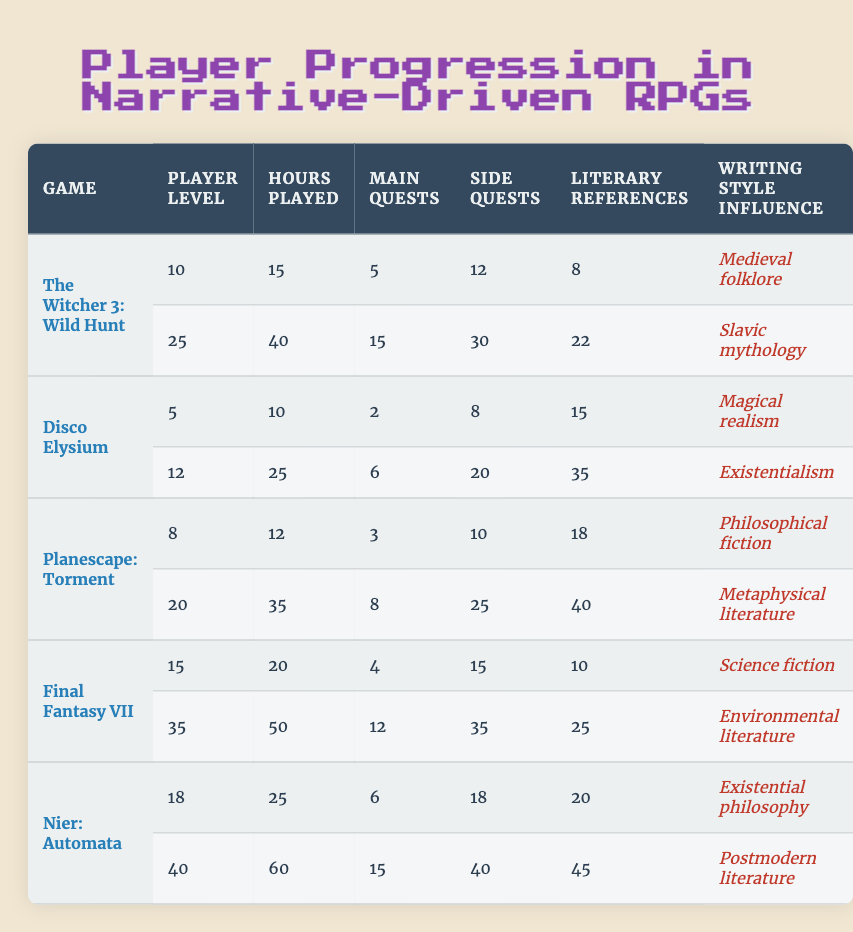What's the highest player level achieved in "Final Fantasy VII"? From the table, "Final Fantasy VII" shows two entries: one with a player level of 15 and another with a level of 35. Therefore, the highest player level is 35.
Answer: 35 Which game has the most hours played across all its entries? The games and their hours are as follows: "The Witcher 3: Wild Hunt" (15 + 40 = 55), "Disco Elysium" (10 + 25 = 35), "Planescape: Torment" (12 + 35 = 47), "Final Fantasy VII" (20 + 50 = 70), and "Nier: Automata" (25 + 60 = 85). So, "Nier: Automata" has the most hours played with a total of 85.
Answer: Nier: Automata How many main quests have been completed in total across all games? To find the total, we sum the main quests completed: 5 (Witcher 3) + 15 (Witcher 3) + 2 (Disco Elysium) + 6 (Disco Elysium) + 3 (Planescape) + 8 (Planescape) + 4 (Final Fantasy) + 12 (Final Fantasy) + 6 (Nier) + 15 (Nier) = 72. Thus, the total of main quests completed is 72.
Answer: 72 Is there a game that has played more than 50 hours at the level of 40? From the table, "Nier: Automata" is the only game with a player level of 40 and it has 60 hours played. Therefore, yes, it meets the criteria.
Answer: Yes Which game had the highest number of literary references encountered? The entries detail the literary references for each game: Witcher 3 (8 + 22 = 30), Disco Elysium (15 + 35 = 50), Planescape Torment (18 + 40 = 58), Final Fantasy (10 + 25 = 35), Nier Automata (20 + 45 = 65). The highest literary references encountered is for "Nier: Automata" with a total of 65 references.
Answer: Nier: Automata What is the average number of side quests completed in "Planescape: Torment"? For "Planescape: Torment", the side quests completed are 10 and 25. So, the average would be (10 + 25) / 2 = 17.5. Therefore, rounding to the nearest whole number gives us an average of 18 side quests completed.
Answer: 18 Which writing style influenced the game with the highest player level? The game with the highest player level is "Final Fantasy VII" at level 35, whose writing style influence is "Environmental literature".
Answer: Environmental literature Is there a player who has completed more side quests than main quests? Upon comparing side quests and main quests across all entries, we find that both entries for "Nier: Automata" have side quests (18 and 40) that exceed the main quests (6 and 15) respectively. Therefore, the answer is yes, there are players who completed more side quests than main quests.
Answer: Yes 